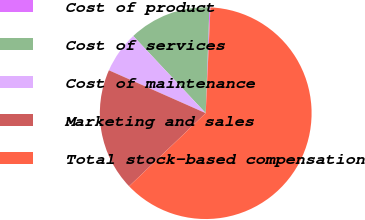<chart> <loc_0><loc_0><loc_500><loc_500><pie_chart><fcel>Cost of product<fcel>Cost of services<fcel>Cost of maintenance<fcel>Marketing and sales<fcel>Total stock-based compensation<nl><fcel>0.16%<fcel>12.56%<fcel>6.36%<fcel>18.76%<fcel>62.16%<nl></chart> 